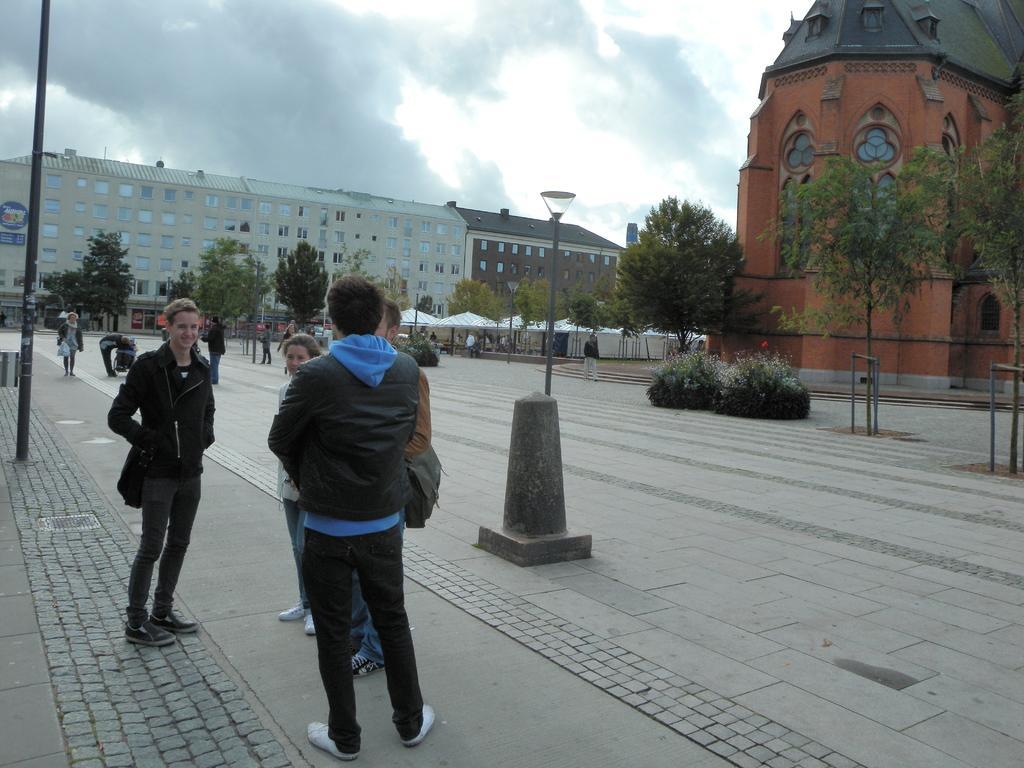Describe this image in one or two sentences. In this image we can see a few people, there are light poles, there are trees, plants, there are buildings, windows, a board on the wall, also we can see the cloudy sky. 